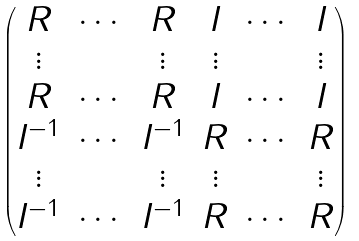Convert formula to latex. <formula><loc_0><loc_0><loc_500><loc_500>\begin{pmatrix} R & \cdots & R & I & \cdots & I \\ \vdots & & \vdots & \vdots & & \vdots \\ R & \cdots & R & I & \cdots & I \\ I ^ { - 1 } & \cdots & I ^ { - 1 } & R & \cdots & R \\ \vdots & & \vdots & \vdots & & \vdots \\ I ^ { - 1 } & \cdots & I ^ { - 1 } & R & \cdots & R \end{pmatrix}</formula> 